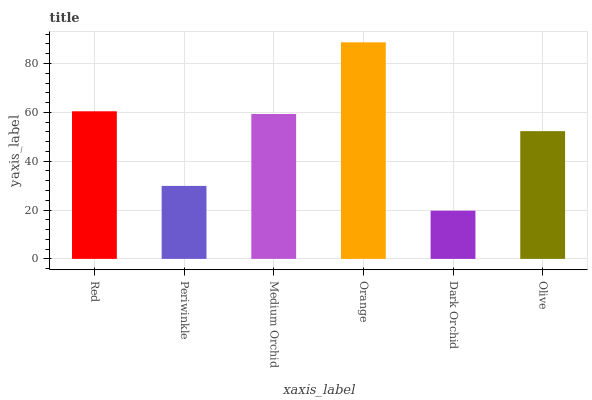Is Dark Orchid the minimum?
Answer yes or no. Yes. Is Orange the maximum?
Answer yes or no. Yes. Is Periwinkle the minimum?
Answer yes or no. No. Is Periwinkle the maximum?
Answer yes or no. No. Is Red greater than Periwinkle?
Answer yes or no. Yes. Is Periwinkle less than Red?
Answer yes or no. Yes. Is Periwinkle greater than Red?
Answer yes or no. No. Is Red less than Periwinkle?
Answer yes or no. No. Is Medium Orchid the high median?
Answer yes or no. Yes. Is Olive the low median?
Answer yes or no. Yes. Is Orange the high median?
Answer yes or no. No. Is Medium Orchid the low median?
Answer yes or no. No. 